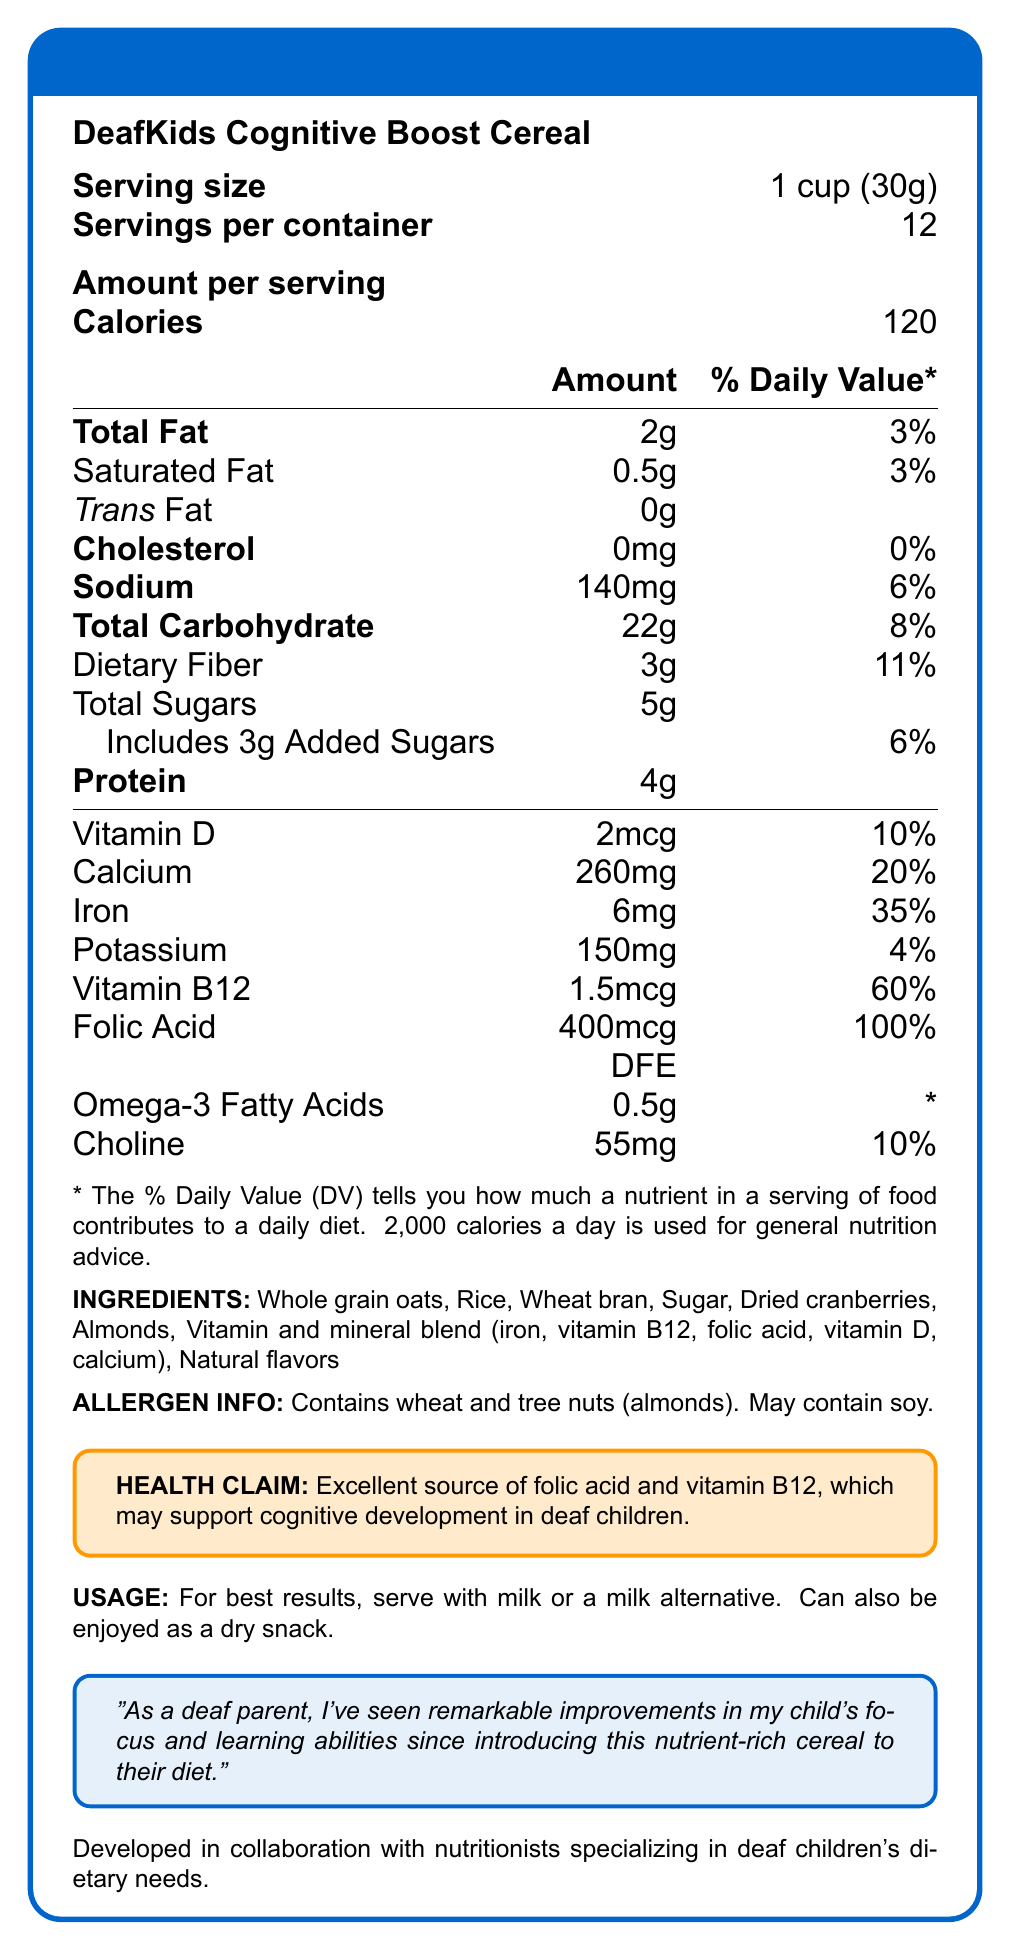what is the serving size for DeafKids Cognitive Boost Cereal? The serving size is mentioned as 1 cup (30g) in the document.
Answer: 1 cup (30g) how many calories are in one serving? The document states that one serving contains 120 calories.
Answer: 120 how much dietary fiber is in each serving? The amount of dietary fiber in each serving is listed as 3g.
Answer: 3g what percentage of the daily value of folic acid does one serving provide? According to the document, one serving provides 100% of the daily value of folic acid.
Answer: 100% does the cereal include any trans fat? yes or no? The document clearly shows that the amount of trans fat is 0g.
Answer: No which vitamins and minerals in this cereal may support cognitive development in deaf children? A. Vitamin C and Calcium B. Folic Acid and Vitamin B12 C. Iron and Potassium D. Vitamin A and Omega-3 fatty acids The health claim section indicates that folic acid and vitamin B12 may support cognitive development in deaf children.
Answer: B which of the following allergens does the cereal contain? A. Soy B. Wheat C. Peanuts D. Dairy The allergen info indicates the cereal contains wheat and tree nuts (almonds) and may contain soy, but not peanuts or dairy.
Answer: B does the cereal contain added sugars? The document specifies that the cereal includes 3g of added sugars.
Answer: Yes summarize the overall nutritional benefits of DeafKids Cognitive Boost Cereal The cereal is described as offering key vitamins and minerals beneficial for cognitive development, with a balanced nutrient profile.
Answer: The cereal is a low-calorie, vitamin-rich food designed to support cognitive development in deaf children. It provides essential nutrients such as folic acid, vitamin B12, and iron, with additional benefits from ingredients like whole grains and almonds. what are the main ingredients in this cereal? The ingredients are listed, showing both the main food components and the added vitamin and mineral blend.
Answer: Whole grain oats, rice, wheat bran, sugar, dried cranberries, almonds, vitamin and mineral blend, natural flavors how much sodium is present in one serving? The sodium content per serving is 140mg according to the document.
Answer: 140mg what is the main idea of the testimonial provided in the document? The testimonial quotes a parent who has noticed positive cognitive benefits in their child from using this product.
Answer: The testimonial states that a deaf parent observed improvements in their child's focus and learning abilities after introducing the cereal into their diet. can the document determine if this cereal is gluten-free? The document mentions that the cereal contains wheat, so it is not gluten-free. However, it does not explicitly state "gluten-free" or provide enough information to verify it as such.
Answer: Cannot be determined how many servings are there per container? The document states there are 12 servings per container.
Answer: 12 